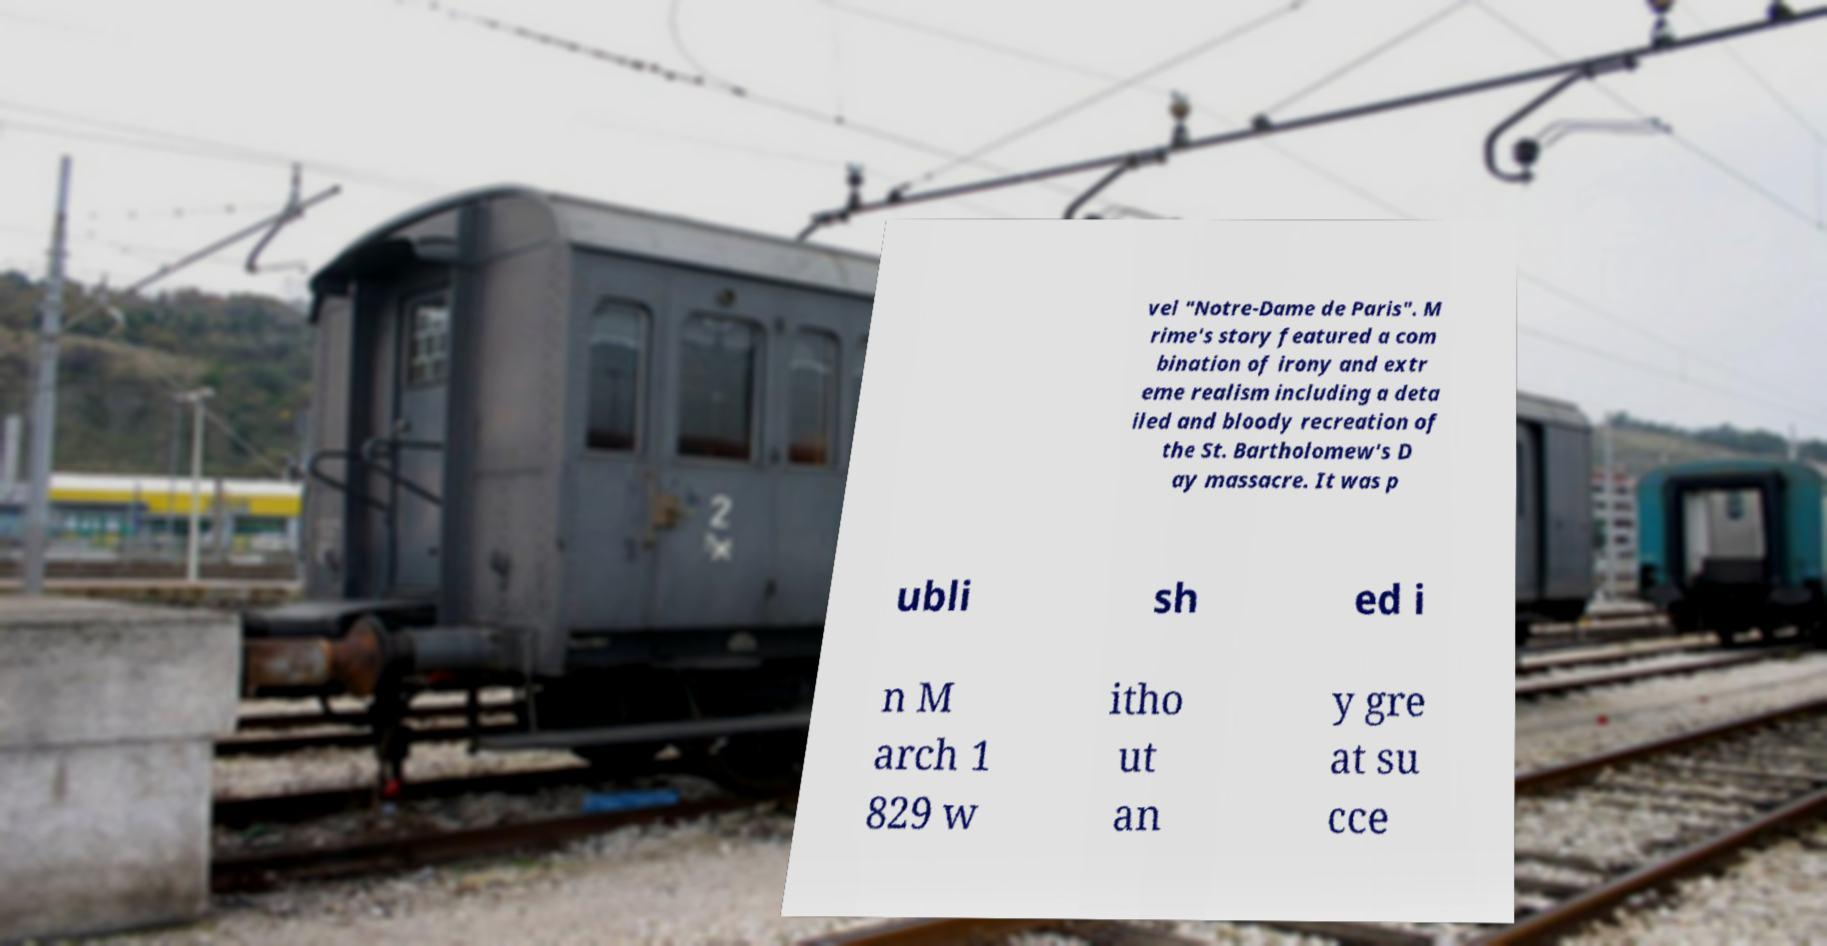There's text embedded in this image that I need extracted. Can you transcribe it verbatim? vel "Notre-Dame de Paris". M rime's story featured a com bination of irony and extr eme realism including a deta iled and bloody recreation of the St. Bartholomew's D ay massacre. It was p ubli sh ed i n M arch 1 829 w itho ut an y gre at su cce 